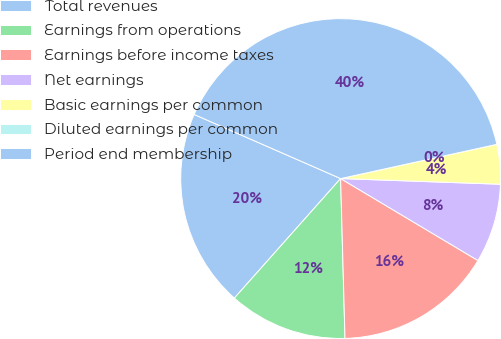<chart> <loc_0><loc_0><loc_500><loc_500><pie_chart><fcel>Total revenues<fcel>Earnings from operations<fcel>Earnings before income taxes<fcel>Net earnings<fcel>Basic earnings per common<fcel>Diluted earnings per common<fcel>Period end membership<nl><fcel>20.0%<fcel>12.0%<fcel>16.0%<fcel>8.0%<fcel>4.0%<fcel>0.0%<fcel>40.0%<nl></chart> 